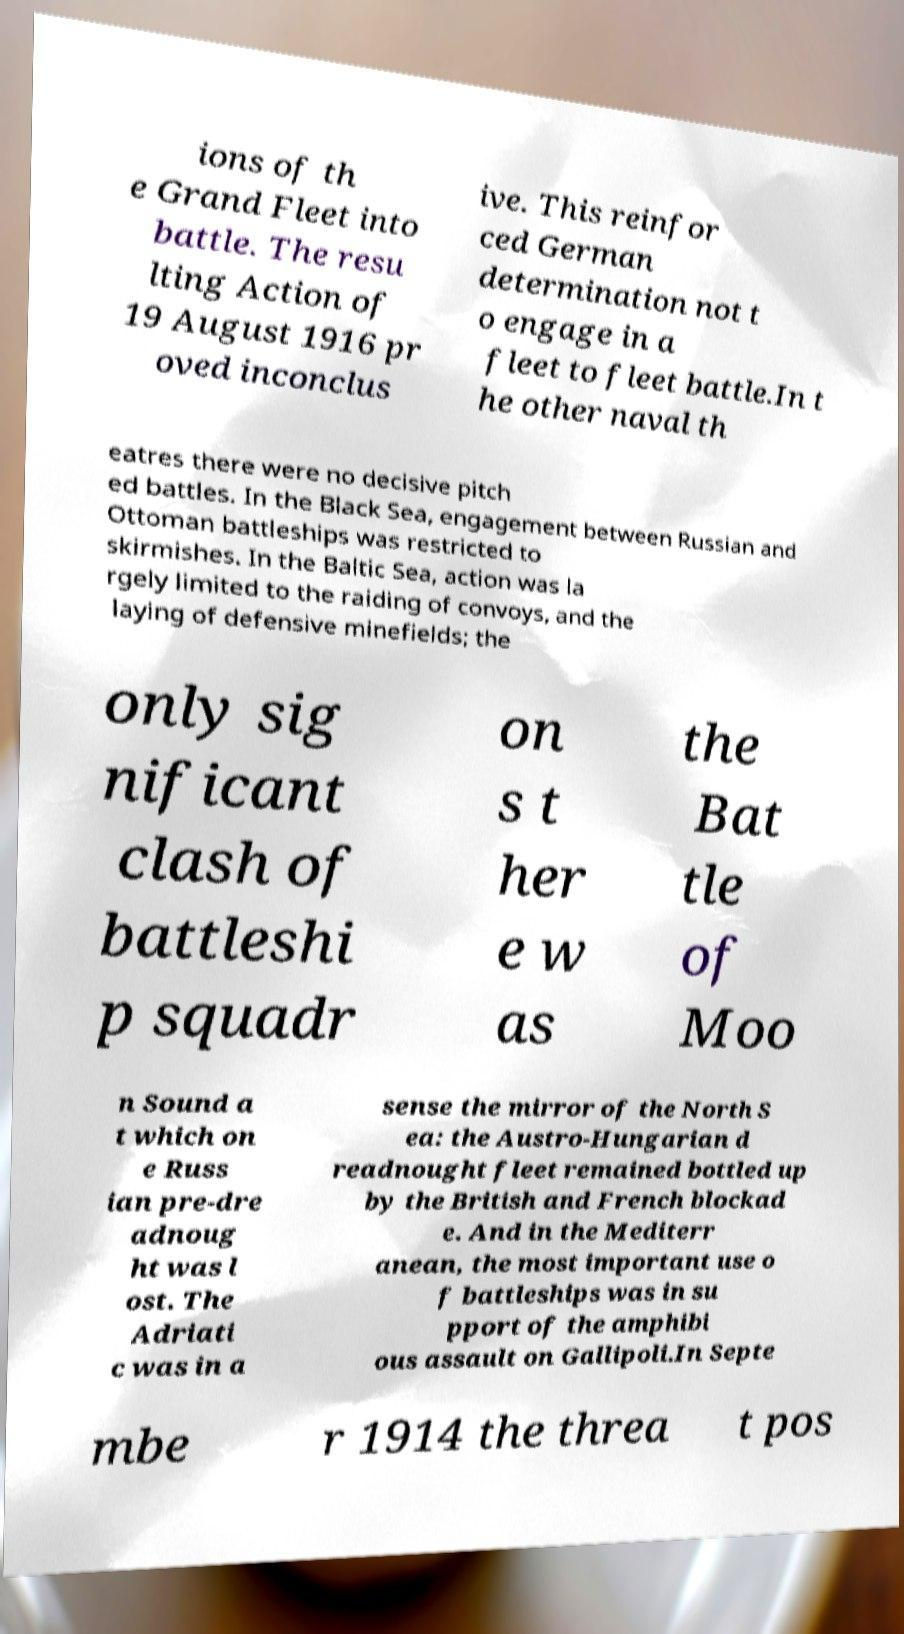Could you assist in decoding the text presented in this image and type it out clearly? ions of th e Grand Fleet into battle. The resu lting Action of 19 August 1916 pr oved inconclus ive. This reinfor ced German determination not t o engage in a fleet to fleet battle.In t he other naval th eatres there were no decisive pitch ed battles. In the Black Sea, engagement between Russian and Ottoman battleships was restricted to skirmishes. In the Baltic Sea, action was la rgely limited to the raiding of convoys, and the laying of defensive minefields; the only sig nificant clash of battleshi p squadr on s t her e w as the Bat tle of Moo n Sound a t which on e Russ ian pre-dre adnoug ht was l ost. The Adriati c was in a sense the mirror of the North S ea: the Austro-Hungarian d readnought fleet remained bottled up by the British and French blockad e. And in the Mediterr anean, the most important use o f battleships was in su pport of the amphibi ous assault on Gallipoli.In Septe mbe r 1914 the threa t pos 